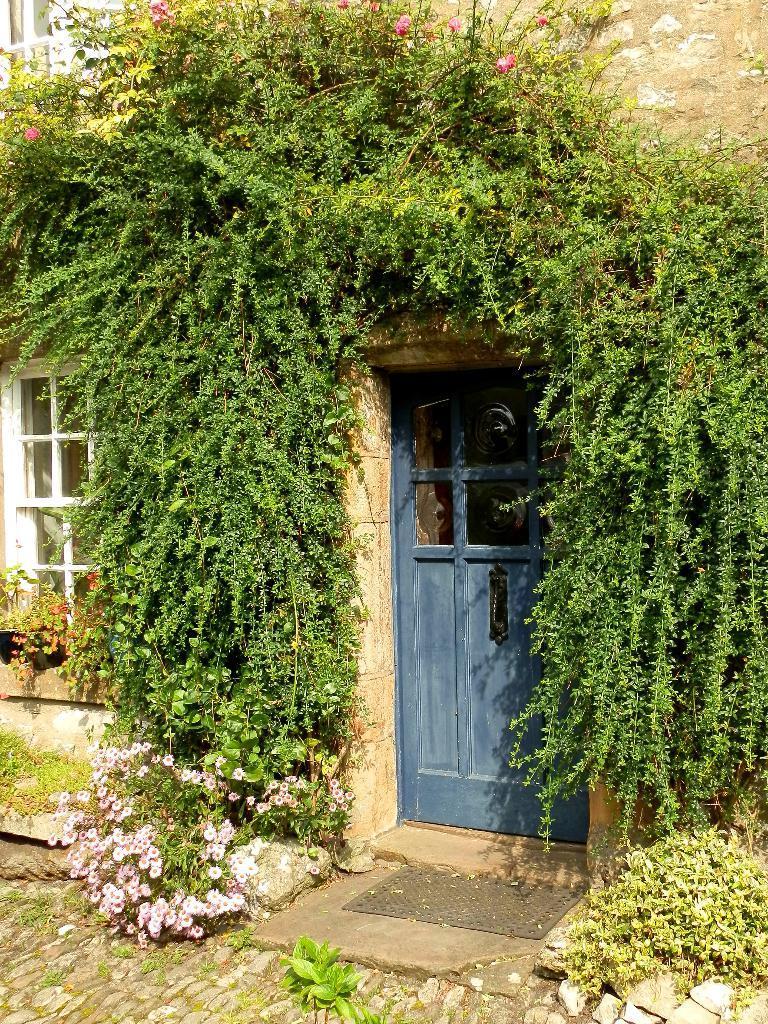Could you give a brief overview of what you see in this image? This is a building and here we can see a creepers, plants and flowers and there are windows and we can see a door. At the bottom, there are rocks on the ground and there is a mat. 